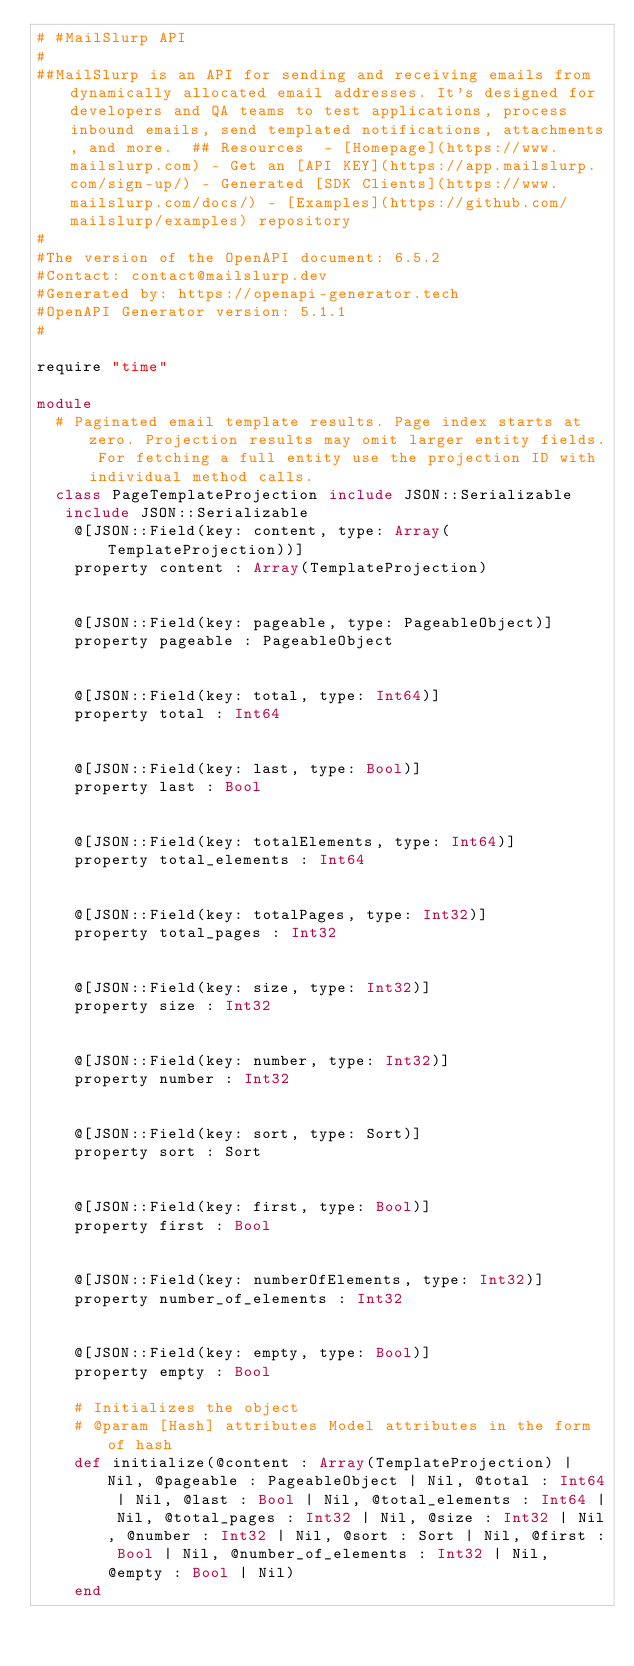Convert code to text. <code><loc_0><loc_0><loc_500><loc_500><_Crystal_># #MailSlurp API
#
##MailSlurp is an API for sending and receiving emails from dynamically allocated email addresses. It's designed for developers and QA teams to test applications, process inbound emails, send templated notifications, attachments, and more.  ## Resources  - [Homepage](https://www.mailslurp.com) - Get an [API KEY](https://app.mailslurp.com/sign-up/) - Generated [SDK Clients](https://www.mailslurp.com/docs/) - [Examples](https://github.com/mailslurp/examples) repository
#
#The version of the OpenAPI document: 6.5.2
#Contact: contact@mailslurp.dev
#Generated by: https://openapi-generator.tech
#OpenAPI Generator version: 5.1.1
#

require "time"

module 
  # Paginated email template results. Page index starts at zero. Projection results may omit larger entity fields. For fetching a full entity use the projection ID with individual method calls.
  class PageTemplateProjection include JSON::Serializable
   include JSON::Serializable 
    @[JSON::Field(key: content, type: Array(TemplateProjection))]
    property content : Array(TemplateProjection)


    @[JSON::Field(key: pageable, type: PageableObject)]
    property pageable : PageableObject


    @[JSON::Field(key: total, type: Int64)]
    property total : Int64


    @[JSON::Field(key: last, type: Bool)]
    property last : Bool


    @[JSON::Field(key: totalElements, type: Int64)]
    property total_elements : Int64


    @[JSON::Field(key: totalPages, type: Int32)]
    property total_pages : Int32


    @[JSON::Field(key: size, type: Int32)]
    property size : Int32


    @[JSON::Field(key: number, type: Int32)]
    property number : Int32


    @[JSON::Field(key: sort, type: Sort)]
    property sort : Sort


    @[JSON::Field(key: first, type: Bool)]
    property first : Bool


    @[JSON::Field(key: numberOfElements, type: Int32)]
    property number_of_elements : Int32


    @[JSON::Field(key: empty, type: Bool)]
    property empty : Bool

    # Initializes the object
    # @param [Hash] attributes Model attributes in the form of hash
    def initialize(@content : Array(TemplateProjection) | Nil, @pageable : PageableObject | Nil, @total : Int64 | Nil, @last : Bool | Nil, @total_elements : Int64 | Nil, @total_pages : Int32 | Nil, @size : Int32 | Nil, @number : Int32 | Nil, @sort : Sort | Nil, @first : Bool | Nil, @number_of_elements : Int32 | Nil, @empty : Bool | Nil)
    end
</code> 